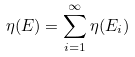<formula> <loc_0><loc_0><loc_500><loc_500>\eta ( E ) = \sum _ { i = 1 } ^ { \infty } \eta ( E _ { i } )</formula> 